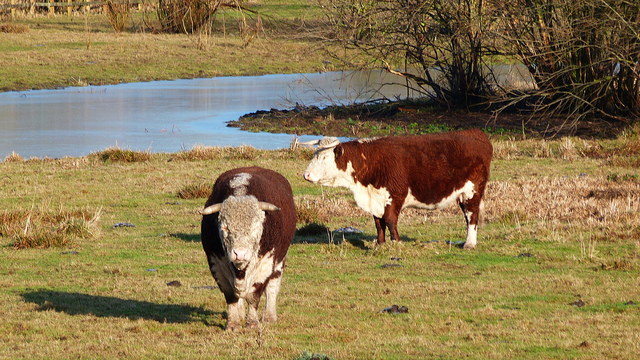Could you describe the environment in which the cows are situated? Certainly! The cows are in a spacious pasture with a mix of grassy areas and patches of bare earth, indicative of well-trodden ground. Behind them is a water body that reflects the clear sky, hinting at a natural, serene setting possibly away from urban areas. Trees at the farther end of the pasture add a touch of woodland charm to the landscape. 